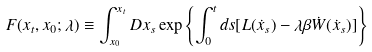<formula> <loc_0><loc_0><loc_500><loc_500>F ( x _ { t } , x _ { 0 } ; \lambda ) \equiv \int _ { x _ { 0 } } ^ { x _ { t } } D x _ { s } \exp { \left \{ \int _ { 0 } ^ { t } d s [ L ( \dot { x } _ { s } ) - \lambda \beta \dot { W } ( \dot { x } _ { s } ) ] \right \} }</formula> 